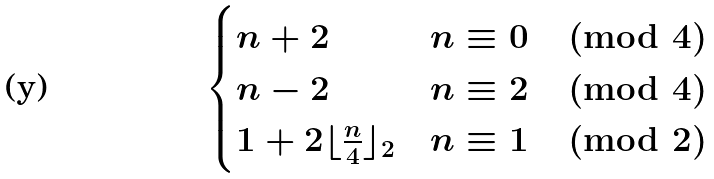Convert formula to latex. <formula><loc_0><loc_0><loc_500><loc_500>\begin{cases} n + 2 & n \equiv 0 \pmod { 4 } \\ n - 2 & n \equiv 2 \pmod { 4 } \\ 1 + 2 \lfloor \frac { n } { 4 } \rfloor _ { 2 } & n \equiv 1 \pmod { 2 } \end{cases}</formula> 